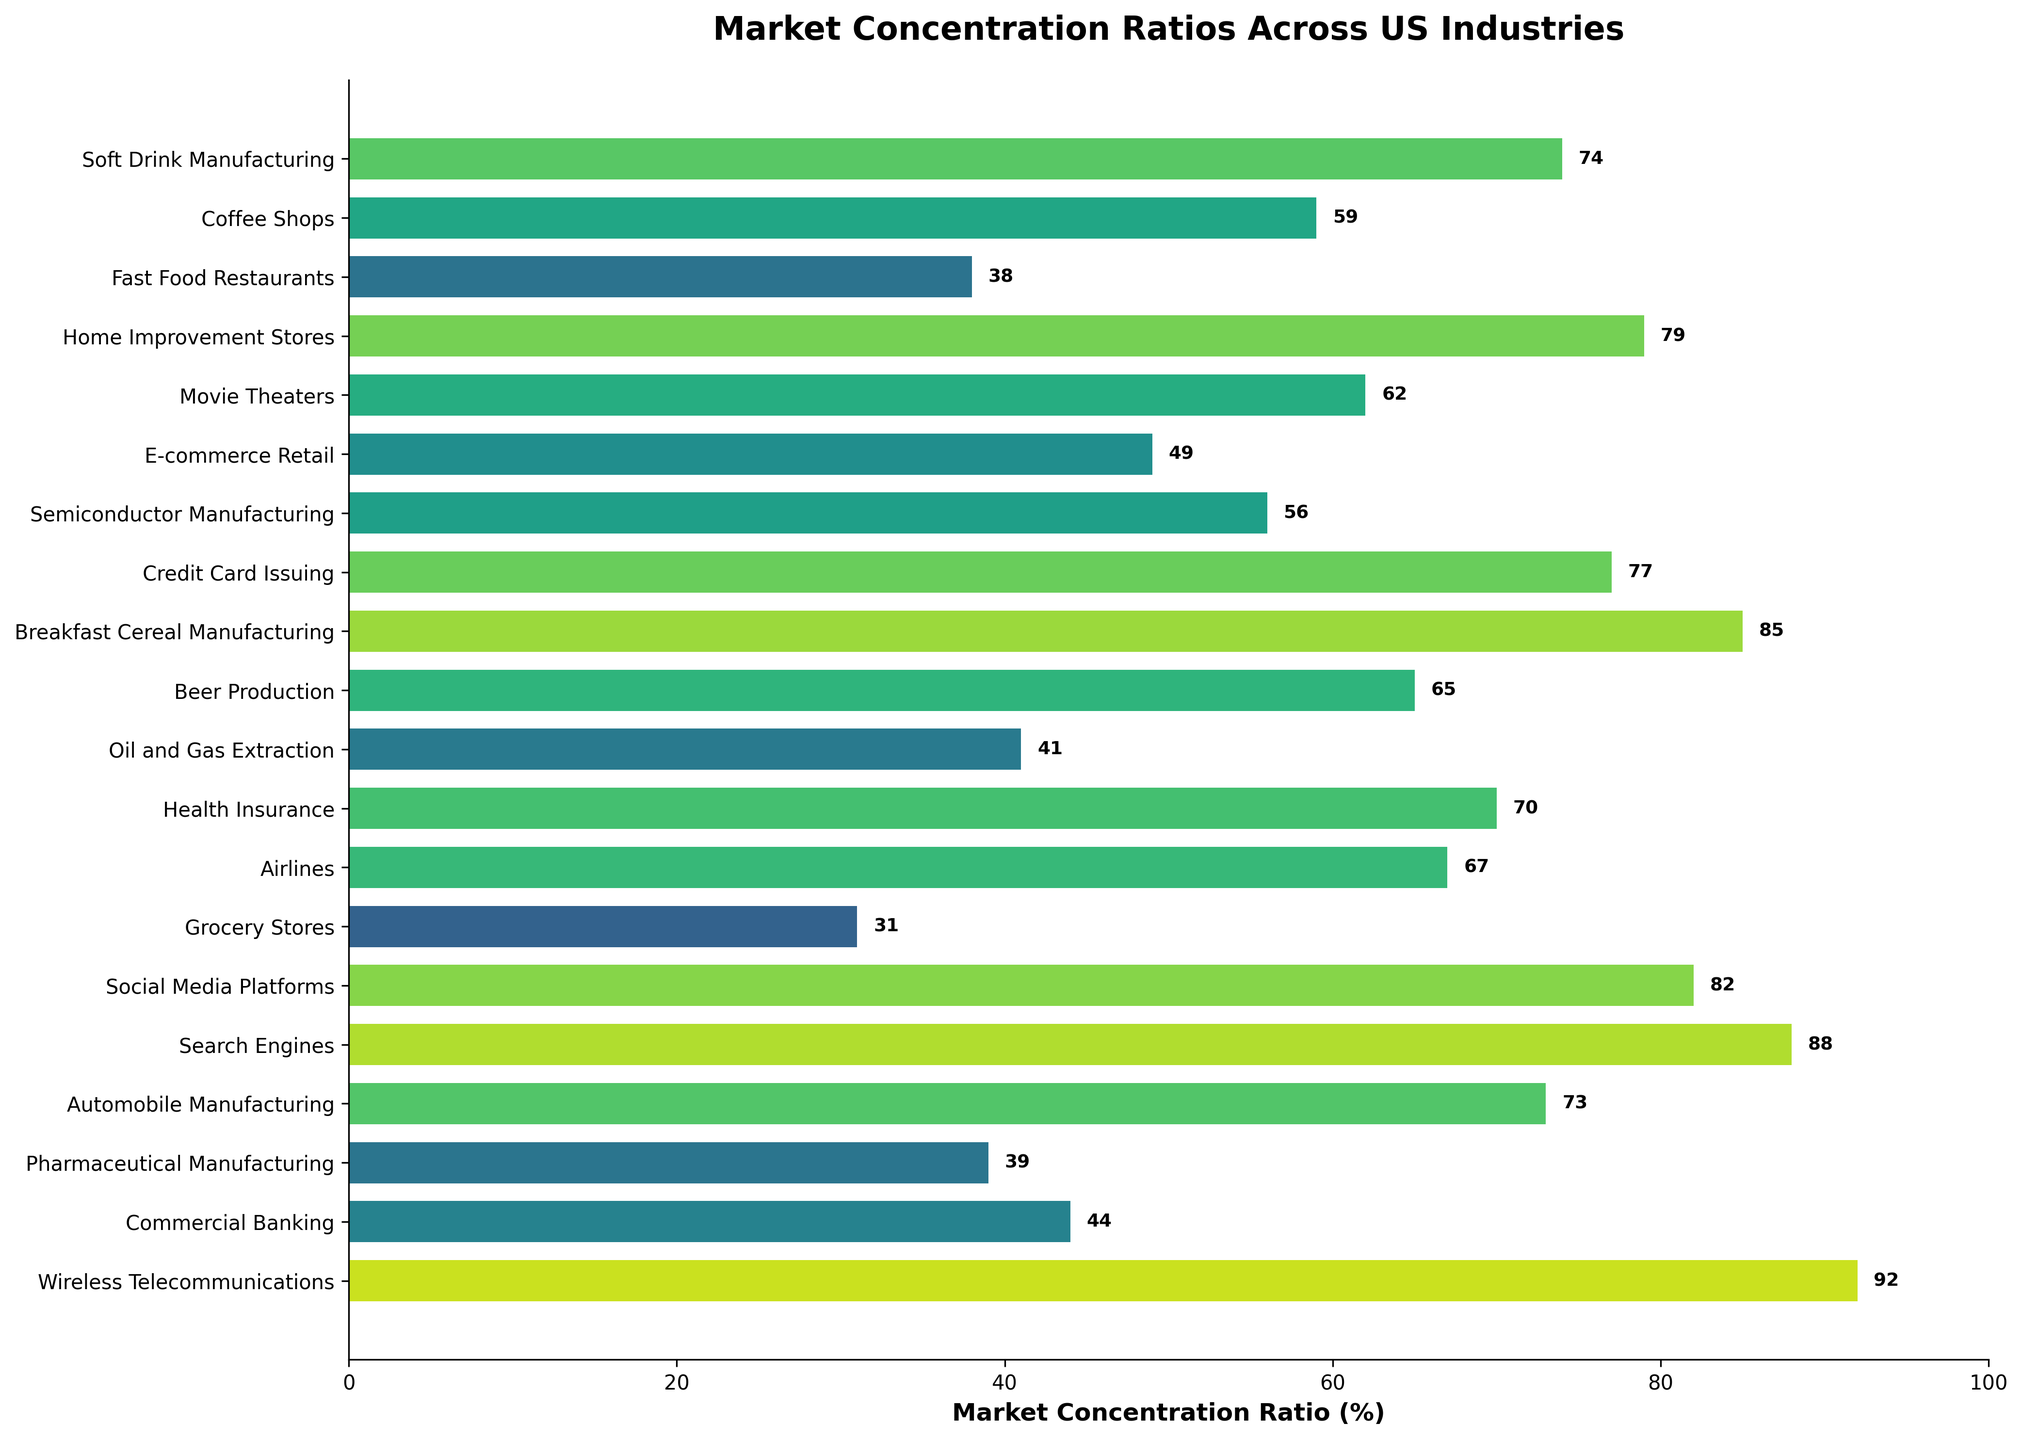Which industry has the highest market concentration ratio? To determine this, look for the bar with the highest percentage value in the figure. The industry corresponding to this bar represents the highest market concentration ratio.
Answer: Wireless Telecommunications Which industry has the lowest market concentration ratio? To find the industry with the lowest ratio, identify the bar with the smallest percentage value in the figure. This industry represents the lowest market concentration ratio.
Answer: Grocery Stores How many industries have a market concentration ratio of 70% or higher? Count the number of bars with a percentage of 70% or more. This count represents the number of highly concentrated industries.
Answer: 10 Which two industries have concentration ratios closest to each other? Identify two bars with the closest percentage values. Compare these values to find the smallest difference between them.
Answer: Coffee Shops (59%) and Semiconductor Manufacturing (56%) Which sector has a higher concentration ratio, Health Insurance or Airlines? Compare the two specified bars. Identify which has a higher value.
Answer: Health Insurance What is the average market concentration ratio of the four industries with the lowest ratios? Identify the industries with the lowest four ratios (Grocery Stores, Fast Food Restaurants, Pharmaceutical Manufacturing, Oil and Gas Extraction). Add these values and divide by 4 to find the average.
Answer: (31 + 38 + 39 + 41) / 4 = 37.25 What is the total market concentration percentage of Home Improvement Stores and Soft Drink Manufacturing? Add the percentages of the specified industries to find the total market concentration percentage.
Answer: 79 + 74 = 153 Are there more industries with concentration ratios above 50% or below 50%? Count the number of industries in each category (above 50% and below 50%). Determine which count is higher.
Answer: More industries above 50% What is the median market concentration ratio across all listed industries? Arrange the ratios in ascending order and find the middle value(s). If there are an even number of industries, average the two middle values.
Answer: (4th and 5th middle) (44 + 49) / 2 = 46.5 What is the combined concentration of the industries involved in technology (Search Engines and Social Media Platforms)? Add the concentration percentages of the specified technology-related industries.
Answer: 88 + 82 = 170 